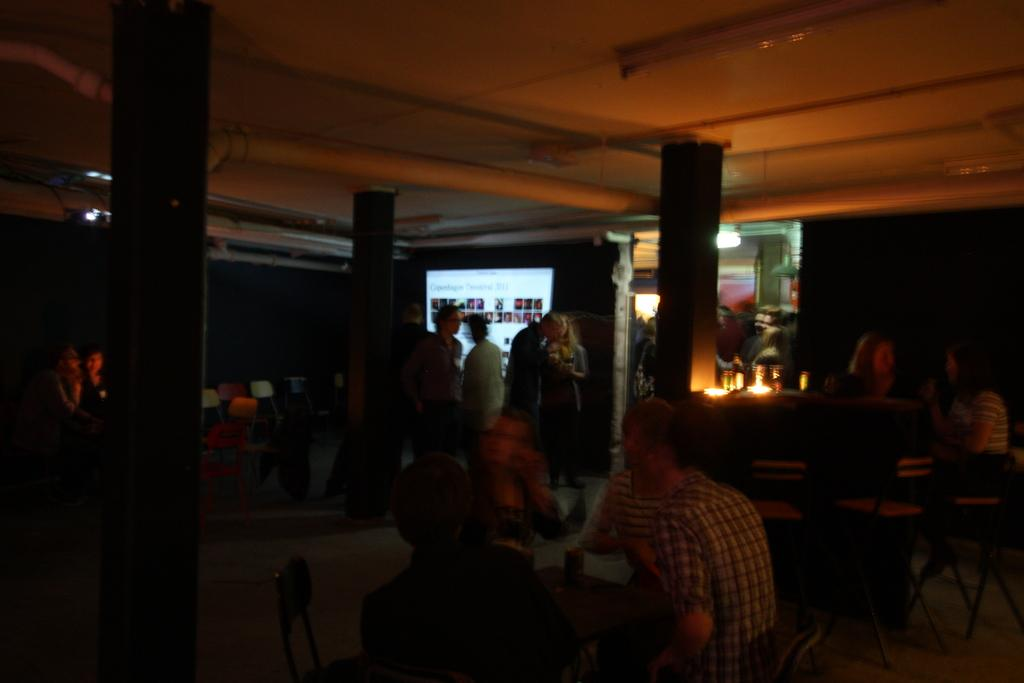How many people are in the image? There is a group of people in the image. What are the people in the image doing? Some people are sitting, while others are standing. What can be seen in the background of the image? There are lights and a screen visible in the background. Can you tell me how many ladybugs are crawling on the screen in the image? There are no ladybugs present in the image; the screen is the only element mentioned in the background. 